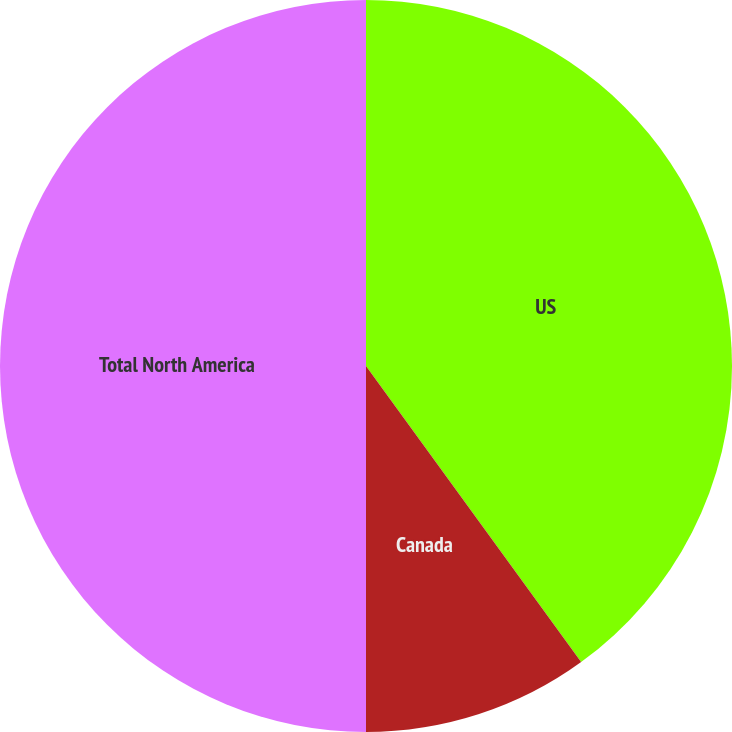<chart> <loc_0><loc_0><loc_500><loc_500><pie_chart><fcel>US<fcel>Canada<fcel>Total North America<nl><fcel>40.0%<fcel>10.0%<fcel>50.0%<nl></chart> 